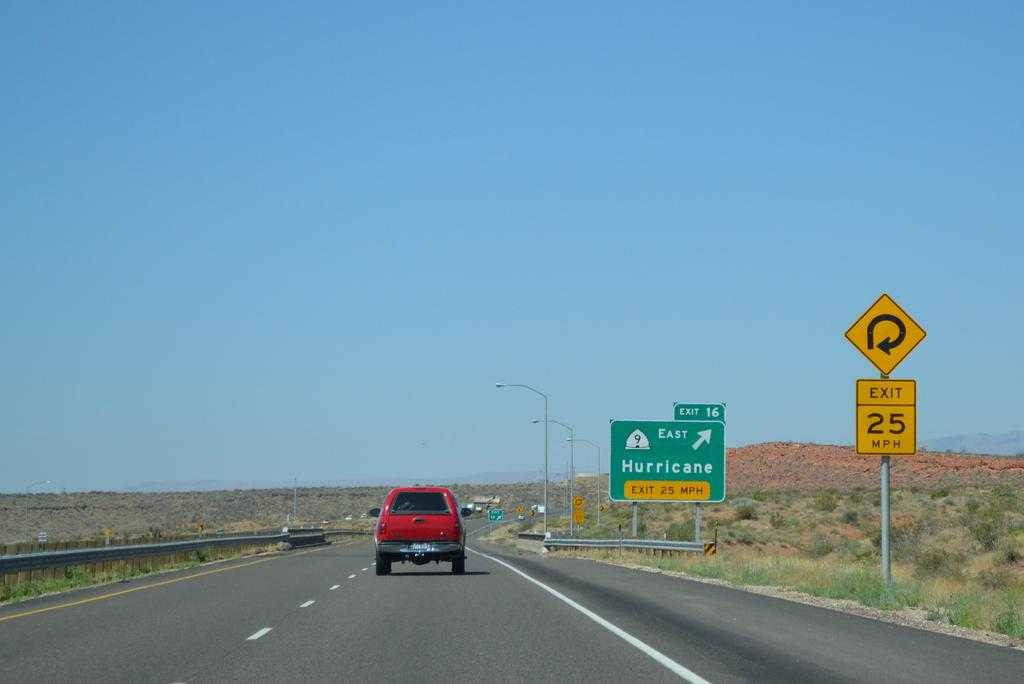<image>
Give a short and clear explanation of the subsequent image. Interstate 15 in Utah for exit 16 to Hurricane. 